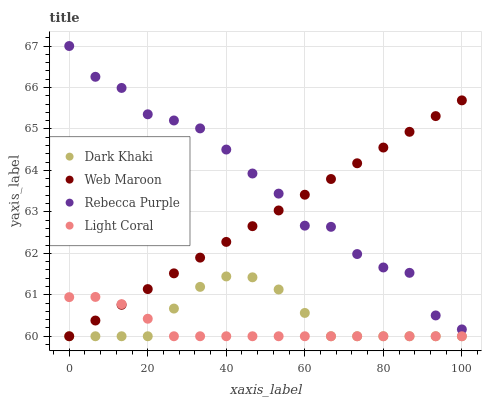Does Light Coral have the minimum area under the curve?
Answer yes or no. Yes. Does Rebecca Purple have the maximum area under the curve?
Answer yes or no. Yes. Does Web Maroon have the minimum area under the curve?
Answer yes or no. No. Does Web Maroon have the maximum area under the curve?
Answer yes or no. No. Is Web Maroon the smoothest?
Answer yes or no. Yes. Is Rebecca Purple the roughest?
Answer yes or no. Yes. Is Light Coral the smoothest?
Answer yes or no. No. Is Light Coral the roughest?
Answer yes or no. No. Does Dark Khaki have the lowest value?
Answer yes or no. Yes. Does Rebecca Purple have the lowest value?
Answer yes or no. No. Does Rebecca Purple have the highest value?
Answer yes or no. Yes. Does Web Maroon have the highest value?
Answer yes or no. No. Is Dark Khaki less than Rebecca Purple?
Answer yes or no. Yes. Is Rebecca Purple greater than Light Coral?
Answer yes or no. Yes. Does Rebecca Purple intersect Web Maroon?
Answer yes or no. Yes. Is Rebecca Purple less than Web Maroon?
Answer yes or no. No. Is Rebecca Purple greater than Web Maroon?
Answer yes or no. No. Does Dark Khaki intersect Rebecca Purple?
Answer yes or no. No. 